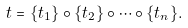<formula> <loc_0><loc_0><loc_500><loc_500>t = \{ t _ { 1 } \} \circ \{ t _ { 2 } \} \circ \cdots \circ \{ t _ { n } \} .</formula> 